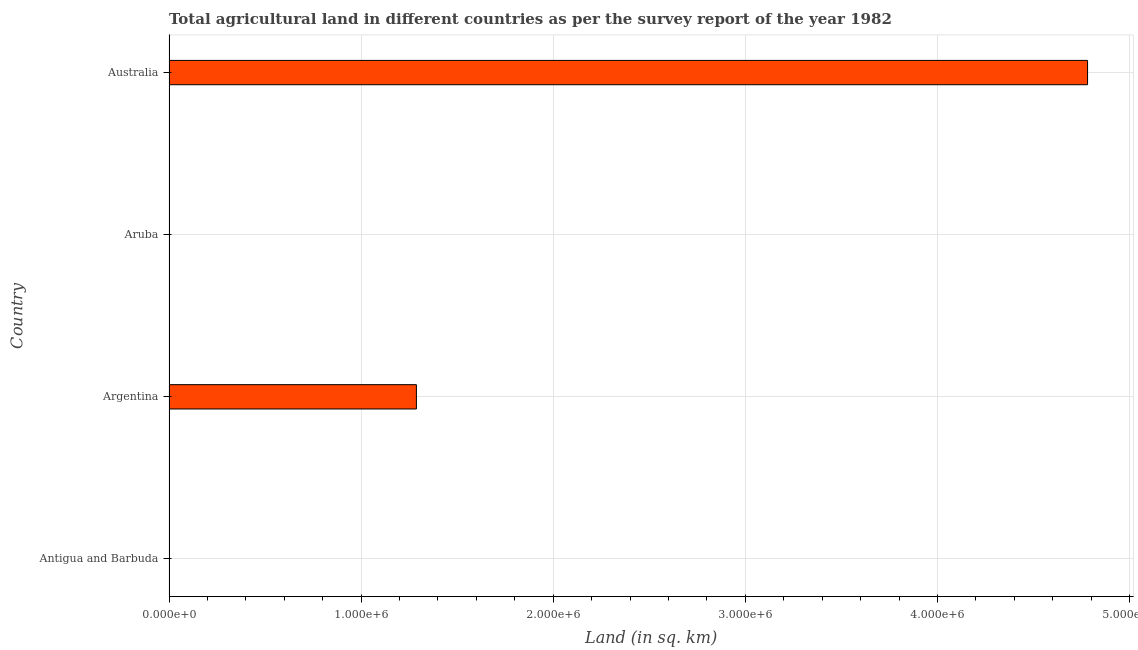What is the title of the graph?
Keep it short and to the point. Total agricultural land in different countries as per the survey report of the year 1982. What is the label or title of the X-axis?
Provide a succinct answer. Land (in sq. km). What is the agricultural land in Australia?
Keep it short and to the point. 4.78e+06. Across all countries, what is the maximum agricultural land?
Make the answer very short. 4.78e+06. In which country was the agricultural land maximum?
Your response must be concise. Australia. In which country was the agricultural land minimum?
Ensure brevity in your answer.  Aruba. What is the sum of the agricultural land?
Make the answer very short. 6.07e+06. What is the difference between the agricultural land in Argentina and Aruba?
Your answer should be very brief. 1.29e+06. What is the average agricultural land per country?
Provide a short and direct response. 1.52e+06. What is the median agricultural land?
Your answer should be compact. 6.44e+05. In how many countries, is the agricultural land greater than 4600000 sq. km?
Provide a short and direct response. 1. Is the agricultural land in Argentina less than that in Australia?
Ensure brevity in your answer.  Yes. Is the difference between the agricultural land in Antigua and Barbuda and Argentina greater than the difference between any two countries?
Provide a short and direct response. No. What is the difference between the highest and the second highest agricultural land?
Ensure brevity in your answer.  3.49e+06. What is the difference between the highest and the lowest agricultural land?
Offer a very short reply. 4.78e+06. In how many countries, is the agricultural land greater than the average agricultural land taken over all countries?
Make the answer very short. 1. How many bars are there?
Provide a succinct answer. 4. Are all the bars in the graph horizontal?
Your answer should be very brief. Yes. How many countries are there in the graph?
Your response must be concise. 4. What is the difference between two consecutive major ticks on the X-axis?
Offer a terse response. 1.00e+06. What is the Land (in sq. km) of Argentina?
Offer a terse response. 1.29e+06. What is the Land (in sq. km) of Australia?
Offer a terse response. 4.78e+06. What is the difference between the Land (in sq. km) in Antigua and Barbuda and Argentina?
Your answer should be compact. -1.29e+06. What is the difference between the Land (in sq. km) in Antigua and Barbuda and Aruba?
Keep it short and to the point. 50. What is the difference between the Land (in sq. km) in Antigua and Barbuda and Australia?
Make the answer very short. -4.78e+06. What is the difference between the Land (in sq. km) in Argentina and Aruba?
Make the answer very short. 1.29e+06. What is the difference between the Land (in sq. km) in Argentina and Australia?
Offer a terse response. -3.49e+06. What is the difference between the Land (in sq. km) in Aruba and Australia?
Offer a very short reply. -4.78e+06. What is the ratio of the Land (in sq. km) in Antigua and Barbuda to that in Aruba?
Your answer should be compact. 3.5. What is the ratio of the Land (in sq. km) in Antigua and Barbuda to that in Australia?
Your answer should be compact. 0. What is the ratio of the Land (in sq. km) in Argentina to that in Aruba?
Give a very brief answer. 6.44e+04. What is the ratio of the Land (in sq. km) in Argentina to that in Australia?
Provide a short and direct response. 0.27. 